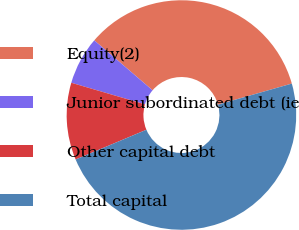Convert chart. <chart><loc_0><loc_0><loc_500><loc_500><pie_chart><fcel>Equity(2)<fcel>Junior subordinated debt (ie<fcel>Other capital debt<fcel>Total capital<nl><fcel>34.31%<fcel>6.74%<fcel>10.87%<fcel>48.08%<nl></chart> 